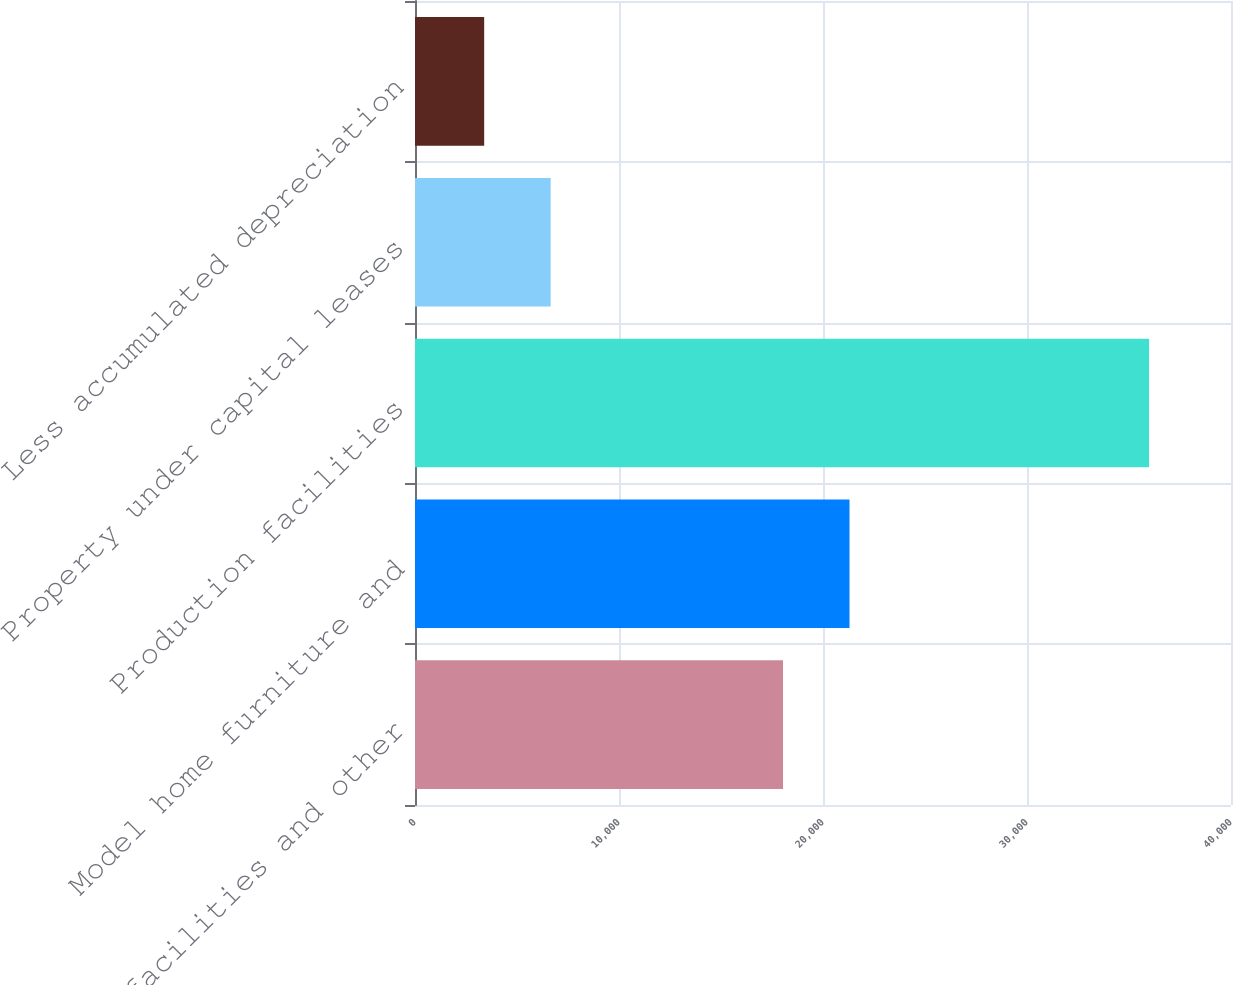Convert chart. <chart><loc_0><loc_0><loc_500><loc_500><bar_chart><fcel>Office facilities and other<fcel>Model home furniture and<fcel>Production facilities<fcel>Property under capital leases<fcel>Less accumulated depreciation<nl><fcel>18040<fcel>21299.2<fcel>35983<fcel>6650.2<fcel>3391<nl></chart> 